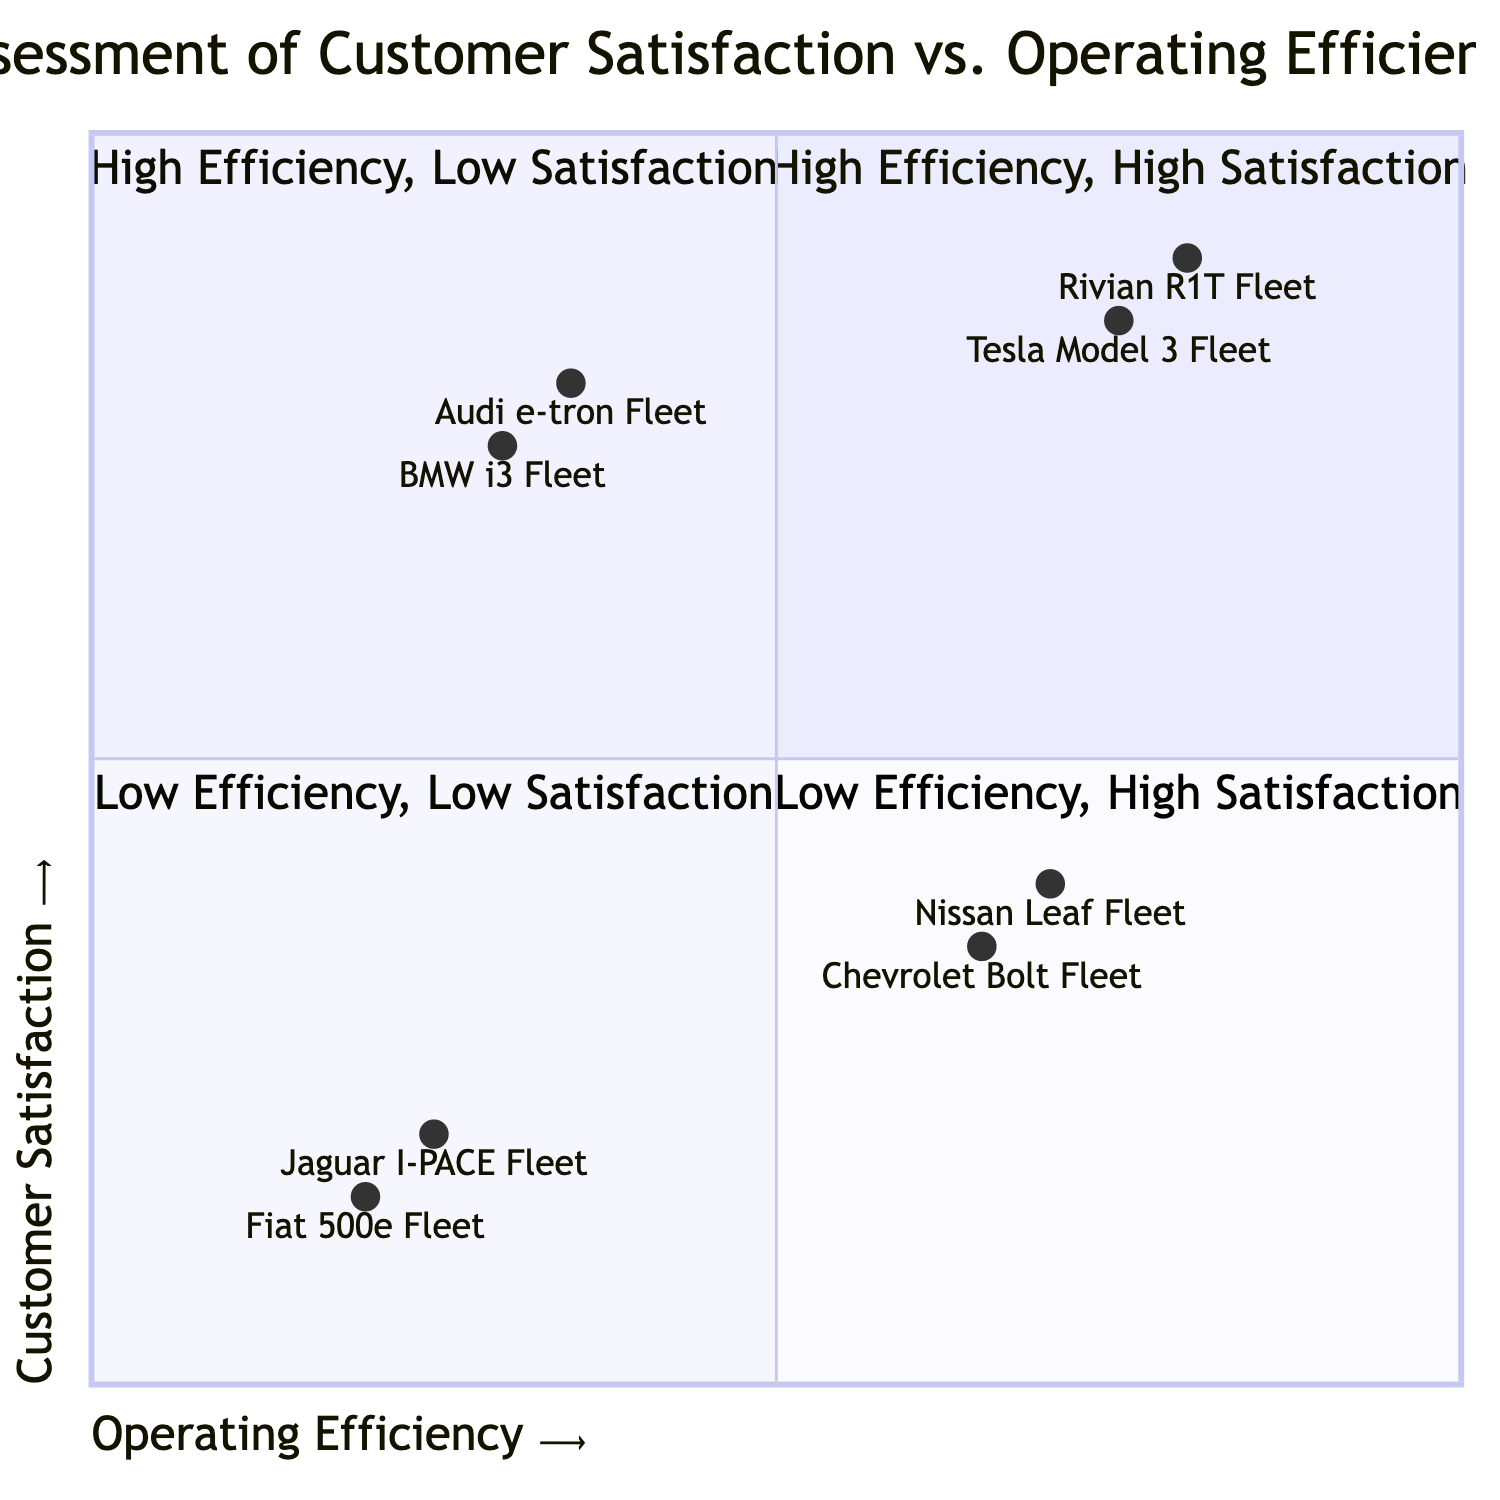What are the two fleets in the High Efficiency, High Satisfaction quadrant? The High Efficiency, High Satisfaction quadrant contains the Tesla Model 3 Fleet and Rivian R1T Fleet. This can be identified by looking at the elements listed in that specific quadrant of the chart.
Answer: Tesla Model 3 Fleet, Rivian R1T Fleet How many fleets are in the Low Efficiency, Low Satisfaction quadrant? The Low Efficiency, Low Satisfaction quadrant includes two fleets: Jaguar I-PACE Fleet and Fiat 500e Fleet. Therefore, by counting the elements in that quadrant, we determine there are two fleets.
Answer: 2 What is the highest Customer Satisfaction score among the fleets? By examining the Customer Satisfaction scores of all fleets, the Rivian R1T Fleet has the highest score of 0.90. This score is present in the High Efficiency, High Satisfaction quadrant.
Answer: 0.90 Which fleet has the lowest Operating Efficiency score? Among all fleets, the Fiat 500e Fleet has the lowest Operating Efficiency score of 0.20. This is determined by comparing the Operating Efficiency values assigned to all listed fleets in the diagram.
Answer: Fiat 500e Fleet Which quadrant contains the BMW i3 Fleet? The BMW i3 Fleet is placed in the Low Efficiency, High Satisfaction quadrant. This is identified by looking for the specific fleet in the quadrants defined in the chart.
Answer: Low Efficiency, High Satisfaction What is the Operating Efficiency score for the Nissan Leaf Fleet? The Operating Efficiency score for the Nissan Leaf Fleet is 0.70. This information is found by directly referencing the assigned score for that fleet in the diagram.
Answer: 0.70 How many total fleets are in the diagram? There are a total of six fleets represented in the diagram, which can be found by counting all the fleets listed across the four quadrants.
Answer: 6 Which fleet has higher Customer Satisfaction: Chevrolet Bolt or Jaguar I-PACE? The Customer Satisfaction score for the Chevrolet Bolt Fleet is 0.35, while the Jaguar I-PACE Fleet has a score of 0.20. Comparison of these two values shows that the Chevrolet Bolt has higher satisfaction.
Answer: Chevrolet Bolt Fleet In which quadrant would you place a fleet with high efficiency but average satisfaction? A fleet with high efficiency but average satisfaction would fall into the High Efficiency, Low Satisfaction quadrant, as this quadrant represents fleets that are efficient but lack customer satisfaction.
Answer: High Efficiency, Low Satisfaction 